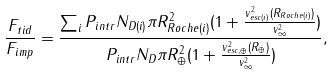<formula> <loc_0><loc_0><loc_500><loc_500>\frac { F _ { t i d } } { F _ { i m p } } = \frac { \sum _ { i } P _ { i n t r } N _ { D ( i ) } \pi R ^ { 2 } _ { R o c h e ( i ) } ( 1 + \frac { v ^ { 2 } _ { e s c ( i ) } ( R _ { R o c h e ( i ) } ) } { v ^ { 2 } _ { \infty } } ) } { P _ { i n t r } N _ { D } \pi R ^ { 2 } _ { \oplus } ( 1 + \frac { v ^ { 2 } _ { e s c , \oplus } ( R _ { \oplus } ) } { v ^ { 2 } _ { \infty } } ) } ,</formula> 